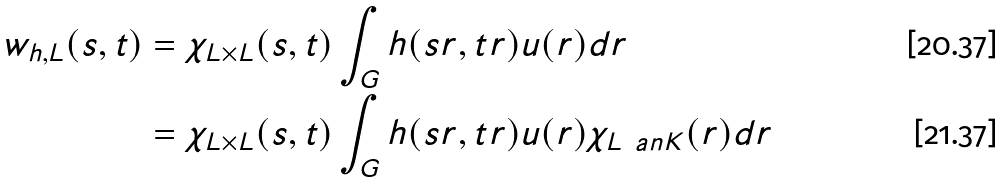<formula> <loc_0><loc_0><loc_500><loc_500>w _ { h , L } ( s , t ) & = \chi _ { L \times L } ( s , t ) \int _ { G } h ( s r , t r ) u ( r ) d r \\ & = \chi _ { L \times L } ( s , t ) \int _ { G } h ( s r , t r ) u ( r ) \chi _ { L \ a n K } ( r ) d r</formula> 